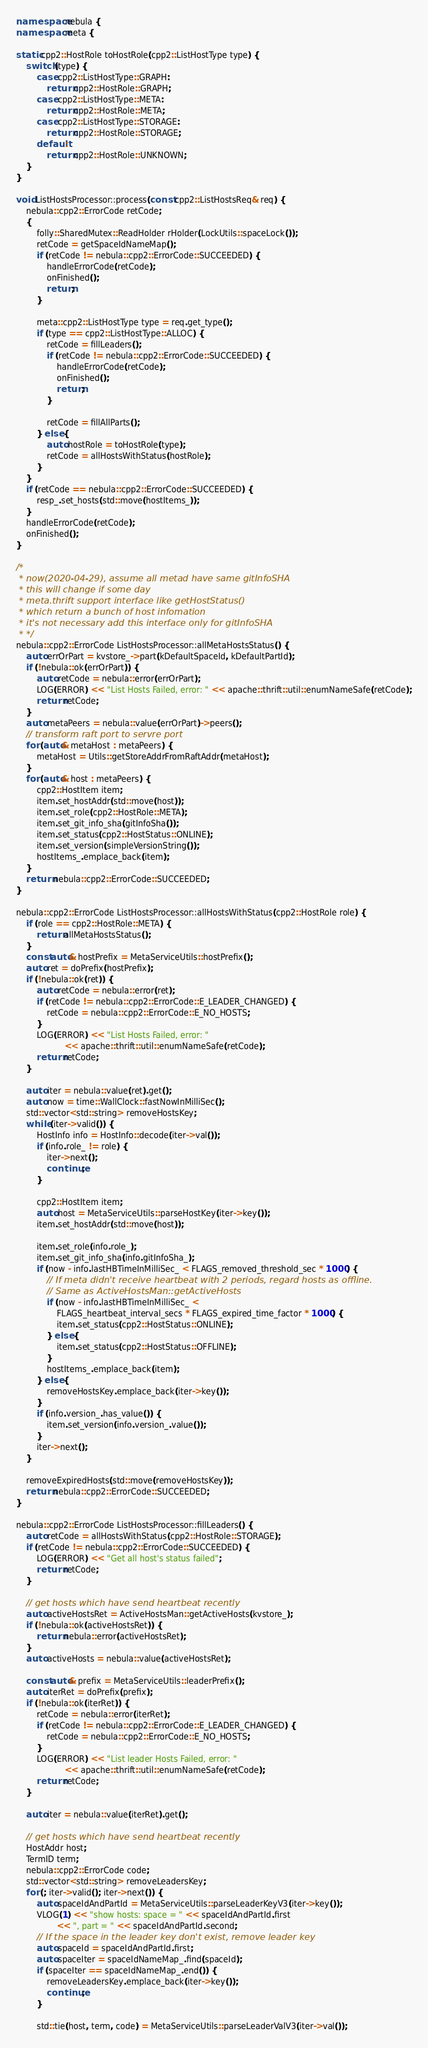Convert code to text. <code><loc_0><loc_0><loc_500><loc_500><_C++_>
namespace nebula {
namespace meta {

static cpp2::HostRole toHostRole(cpp2::ListHostType type) {
    switch (type) {
        case cpp2::ListHostType::GRAPH:
            return cpp2::HostRole::GRAPH;
        case cpp2::ListHostType::META:
            return cpp2::HostRole::META;
        case cpp2::ListHostType::STORAGE:
            return cpp2::HostRole::STORAGE;
        default:
            return cpp2::HostRole::UNKNOWN;
    }
}

void ListHostsProcessor::process(const cpp2::ListHostsReq& req) {
    nebula::cpp2::ErrorCode retCode;
    {
        folly::SharedMutex::ReadHolder rHolder(LockUtils::spaceLock());
        retCode = getSpaceIdNameMap();
        if (retCode != nebula::cpp2::ErrorCode::SUCCEEDED) {
            handleErrorCode(retCode);
            onFinished();
            return;
        }

        meta::cpp2::ListHostType type = req.get_type();
        if (type == cpp2::ListHostType::ALLOC) {
            retCode = fillLeaders();
            if (retCode != nebula::cpp2::ErrorCode::SUCCEEDED) {
                handleErrorCode(retCode);
                onFinished();
                return;
            }

            retCode = fillAllParts();
        } else {
            auto hostRole = toHostRole(type);
            retCode = allHostsWithStatus(hostRole);
        }
    }
    if (retCode == nebula::cpp2::ErrorCode::SUCCEEDED) {
        resp_.set_hosts(std::move(hostItems_));
    }
    handleErrorCode(retCode);
    onFinished();
}

/*
 * now(2020-04-29), assume all metad have same gitInfoSHA
 * this will change if some day
 * meta.thrift support interface like getHostStatus()
 * which return a bunch of host infomation
 * it's not necessary add this interface only for gitInfoSHA
 * */
nebula::cpp2::ErrorCode ListHostsProcessor::allMetaHostsStatus() {
    auto errOrPart = kvstore_->part(kDefaultSpaceId, kDefaultPartId);
    if (!nebula::ok(errOrPart)) {
        auto retCode = nebula::error(errOrPart);
        LOG(ERROR) << "List Hosts Failed, error: " << apache::thrift::util::enumNameSafe(retCode);
        return retCode;
    }
    auto metaPeers = nebula::value(errOrPart)->peers();
    // transform raft port to servre port
    for (auto& metaHost : metaPeers) {
        metaHost = Utils::getStoreAddrFromRaftAddr(metaHost);
    }
    for (auto& host : metaPeers) {
        cpp2::HostItem item;
        item.set_hostAddr(std::move(host));
        item.set_role(cpp2::HostRole::META);
        item.set_git_info_sha(gitInfoSha());
        item.set_status(cpp2::HostStatus::ONLINE);
        item.set_version(simpleVersionString());
        hostItems_.emplace_back(item);
    }
    return nebula::cpp2::ErrorCode::SUCCEEDED;
}

nebula::cpp2::ErrorCode ListHostsProcessor::allHostsWithStatus(cpp2::HostRole role) {
    if (role == cpp2::HostRole::META) {
        return allMetaHostsStatus();
    }
    const auto& hostPrefix = MetaServiceUtils::hostPrefix();
    auto ret = doPrefix(hostPrefix);
    if (!nebula::ok(ret)) {
        auto retCode = nebula::error(ret);
        if (retCode != nebula::cpp2::ErrorCode::E_LEADER_CHANGED) {
            retCode = nebula::cpp2::ErrorCode::E_NO_HOSTS;
        }
        LOG(ERROR) << "List Hosts Failed, error: "
                   << apache::thrift::util::enumNameSafe(retCode);
        return retCode;
    }

    auto iter = nebula::value(ret).get();
    auto now = time::WallClock::fastNowInMilliSec();
    std::vector<std::string> removeHostsKey;
    while (iter->valid()) {
        HostInfo info = HostInfo::decode(iter->val());
        if (info.role_ != role) {
            iter->next();
            continue;
        }

        cpp2::HostItem item;
        auto host = MetaServiceUtils::parseHostKey(iter->key());
        item.set_hostAddr(std::move(host));

        item.set_role(info.role_);
        item.set_git_info_sha(info.gitInfoSha_);
        if (now - info.lastHBTimeInMilliSec_ < FLAGS_removed_threshold_sec * 1000) {
            // If meta didn't receive heartbeat with 2 periods, regard hosts as offline.
            // Same as ActiveHostsMan::getActiveHosts
            if (now - info.lastHBTimeInMilliSec_ <
                FLAGS_heartbeat_interval_secs * FLAGS_expired_time_factor * 1000) {
                item.set_status(cpp2::HostStatus::ONLINE);
            } else {
                item.set_status(cpp2::HostStatus::OFFLINE);
            }
            hostItems_.emplace_back(item);
        } else {
            removeHostsKey.emplace_back(iter->key());
        }
        if (info.version_.has_value()) {
            item.set_version(info.version_.value());
        }
        iter->next();
    }

    removeExpiredHosts(std::move(removeHostsKey));
    return nebula::cpp2::ErrorCode::SUCCEEDED;
}

nebula::cpp2::ErrorCode ListHostsProcessor::fillLeaders() {
    auto retCode = allHostsWithStatus(cpp2::HostRole::STORAGE);
    if (retCode != nebula::cpp2::ErrorCode::SUCCEEDED) {
        LOG(ERROR) << "Get all host's status failed";
        return retCode;
    }

    // get hosts which have send heartbeat recently
    auto activeHostsRet = ActiveHostsMan::getActiveHosts(kvstore_);
    if (!nebula::ok(activeHostsRet)) {
        return nebula::error(activeHostsRet);
    }
    auto activeHosts = nebula::value(activeHostsRet);

    const auto& prefix = MetaServiceUtils::leaderPrefix();
    auto iterRet = doPrefix(prefix);
    if (!nebula::ok(iterRet)) {
        retCode = nebula::error(iterRet);
        if (retCode != nebula::cpp2::ErrorCode::E_LEADER_CHANGED) {
            retCode = nebula::cpp2::ErrorCode::E_NO_HOSTS;
        }
        LOG(ERROR) << "List leader Hosts Failed, error: "
                   << apache::thrift::util::enumNameSafe(retCode);
        return retCode;
    }

    auto iter = nebula::value(iterRet).get();

    // get hosts which have send heartbeat recently
    HostAddr host;
    TermID term;
    nebula::cpp2::ErrorCode code;
    std::vector<std::string> removeLeadersKey;
    for (; iter->valid(); iter->next()) {
        auto spaceIdAndPartId = MetaServiceUtils::parseLeaderKeyV3(iter->key());
        VLOG(1) << "show hosts: space = " << spaceIdAndPartId.first
                << ", part = " << spaceIdAndPartId.second;
        // If the space in the leader key don't exist, remove leader key
        auto spaceId = spaceIdAndPartId.first;
        auto spaceIter = spaceIdNameMap_.find(spaceId);
        if (spaceIter == spaceIdNameMap_.end()) {
            removeLeadersKey.emplace_back(iter->key());
            continue;
        }

        std::tie(host, term, code) = MetaServiceUtils::parseLeaderValV3(iter->val());</code> 